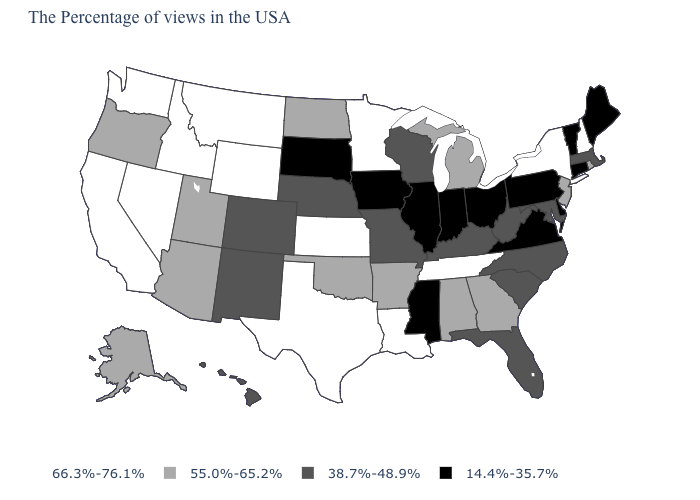Among the states that border Texas , does New Mexico have the lowest value?
Short answer required. Yes. What is the highest value in the USA?
Keep it brief. 66.3%-76.1%. What is the value of West Virginia?
Keep it brief. 38.7%-48.9%. What is the value of New York?
Short answer required. 66.3%-76.1%. Name the states that have a value in the range 66.3%-76.1%?
Quick response, please. New Hampshire, New York, Tennessee, Louisiana, Minnesota, Kansas, Texas, Wyoming, Montana, Idaho, Nevada, California, Washington. Does Nebraska have the lowest value in the USA?
Answer briefly. No. Name the states that have a value in the range 55.0%-65.2%?
Quick response, please. Rhode Island, New Jersey, Georgia, Michigan, Alabama, Arkansas, Oklahoma, North Dakota, Utah, Arizona, Oregon, Alaska. Among the states that border New Jersey , which have the highest value?
Short answer required. New York. Which states have the lowest value in the West?
Keep it brief. Colorado, New Mexico, Hawaii. Name the states that have a value in the range 14.4%-35.7%?
Be succinct. Maine, Vermont, Connecticut, Delaware, Pennsylvania, Virginia, Ohio, Indiana, Illinois, Mississippi, Iowa, South Dakota. What is the value of Tennessee?
Answer briefly. 66.3%-76.1%. Which states hav the highest value in the Northeast?
Answer briefly. New Hampshire, New York. What is the lowest value in the USA?
Write a very short answer. 14.4%-35.7%. What is the value of Florida?
Answer briefly. 38.7%-48.9%. What is the value of Rhode Island?
Quick response, please. 55.0%-65.2%. 